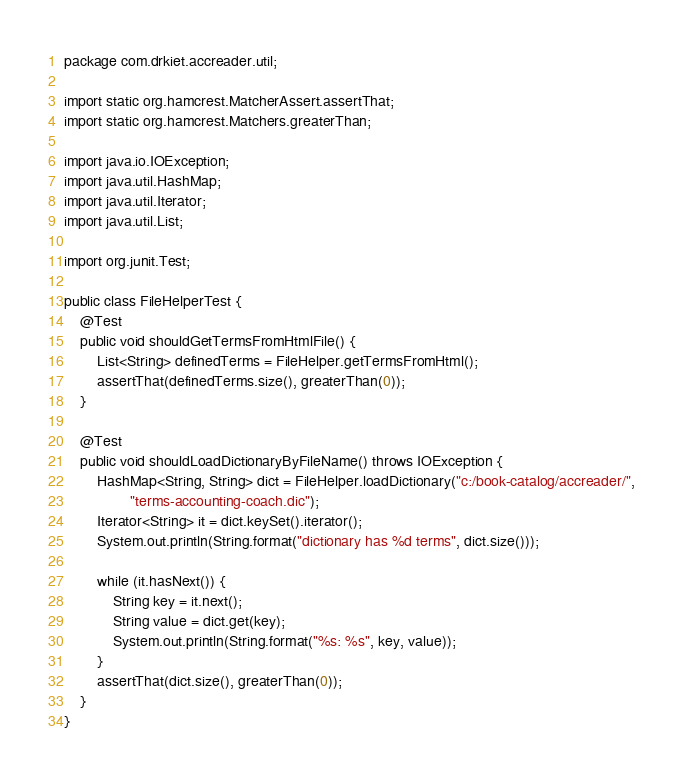Convert code to text. <code><loc_0><loc_0><loc_500><loc_500><_Java_>package com.drkiet.accreader.util;

import static org.hamcrest.MatcherAssert.assertThat;
import static org.hamcrest.Matchers.greaterThan;

import java.io.IOException;
import java.util.HashMap;
import java.util.Iterator;
import java.util.List;

import org.junit.Test;

public class FileHelperTest {
	@Test
	public void shouldGetTermsFromHtmlFile() {
		List<String> definedTerms = FileHelper.getTermsFromHtml();
		assertThat(definedTerms.size(), greaterThan(0));
	}

	@Test
	public void shouldLoadDictionaryByFileName() throws IOException {
		HashMap<String, String> dict = FileHelper.loadDictionary("c:/book-catalog/accreader/",
				"terms-accounting-coach.dic");
		Iterator<String> it = dict.keySet().iterator();
		System.out.println(String.format("dictionary has %d terms", dict.size()));

		while (it.hasNext()) {
			String key = it.next();
			String value = dict.get(key);
			System.out.println(String.format("%s: %s", key, value));
		}
		assertThat(dict.size(), greaterThan(0));
	}
}
</code> 